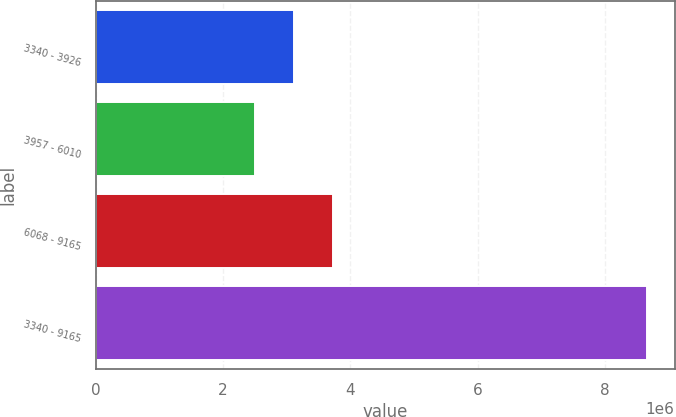Convert chart to OTSL. <chart><loc_0><loc_0><loc_500><loc_500><bar_chart><fcel>3340 - 3926<fcel>3957 - 6010<fcel>6068 - 9165<fcel>3340 - 9165<nl><fcel>3.11937e+06<fcel>2.5037e+06<fcel>3.73503e+06<fcel>8.66034e+06<nl></chart> 